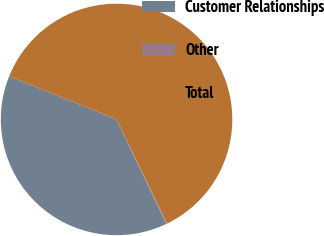Convert chart to OTSL. <chart><loc_0><loc_0><loc_500><loc_500><pie_chart><fcel>Customer Relationships<fcel>Other<fcel>Total<nl><fcel>38.15%<fcel>0.12%<fcel>61.73%<nl></chart> 